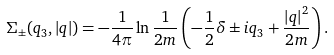Convert formula to latex. <formula><loc_0><loc_0><loc_500><loc_500>\Sigma _ { \pm } ( q _ { 3 } , \left | { q } \right | ) = - \frac { 1 } { 4 \pi } \ln \frac { 1 } { 2 m } \left ( - \frac { 1 } { 2 } \delta \pm i q _ { 3 } + \frac { \left | { q } \right | ^ { 2 } } { 2 m } \right ) .</formula> 